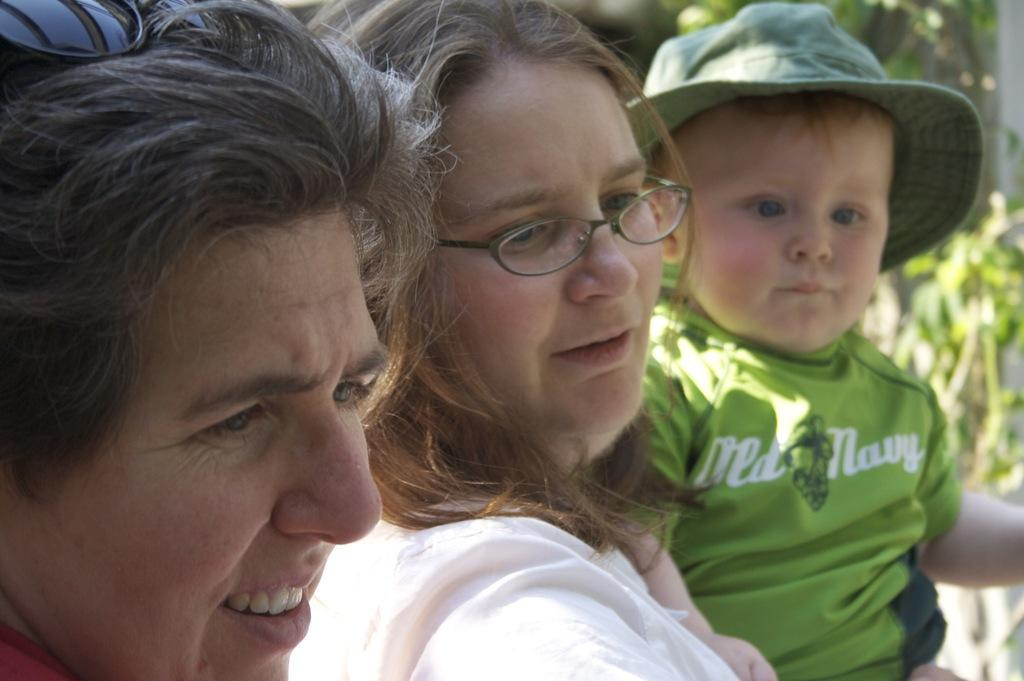How many persons with spectacles can be seen in the image? There are two persons with spectacles in the image. What is the boy in the image wearing on his head? The boy in the image is wearing a hat. Can you describe the background of the image? The background of the image is blurred. What type of pancake is the boy eating in the image? There is no pancake present in the image, and the boy is not eating anything. Can you tell me how many deer are visible in the image? There are no deer present in the image. 